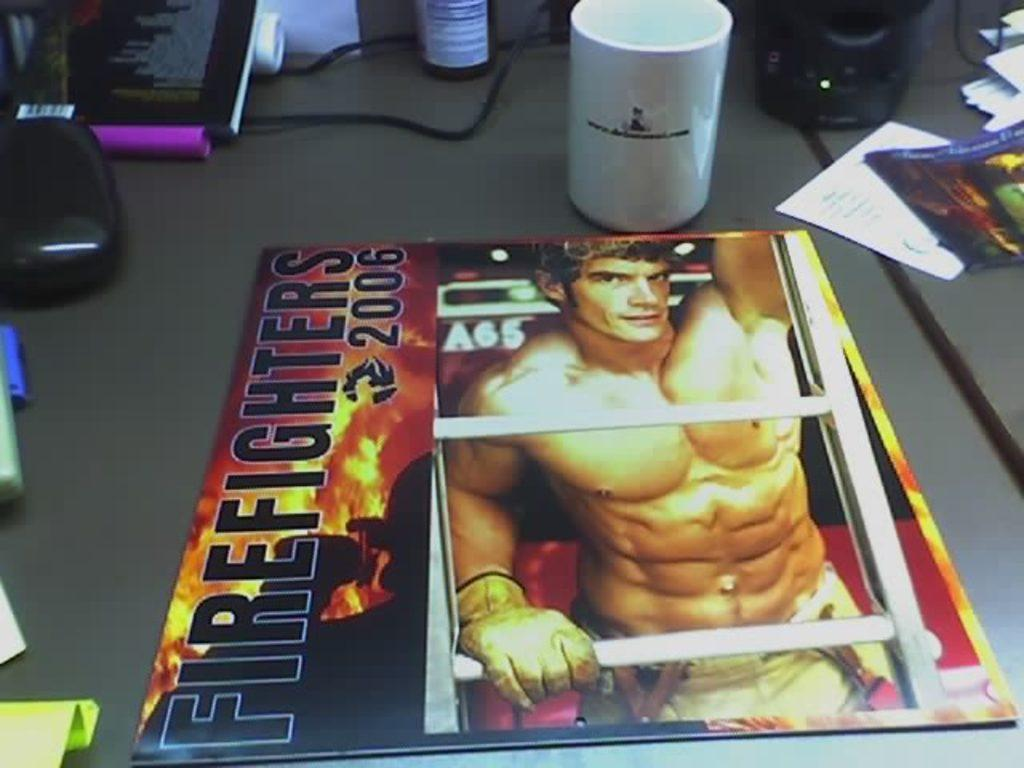What piece of furniture is present in the image? There is a table in the image. What is placed on the table? There is a mug, a book, a bottle, papers, and wires on the table. Can you describe the book on the table? The book has "Firefighter 2006" written on it and has a person's photo printed on it. What else can be seen on the table? There are papers and wires on the table. What type of sign can be seen in the image? There is no sign present in the image. What does the person's dad do in the image? There is no person or dad present in the image. 